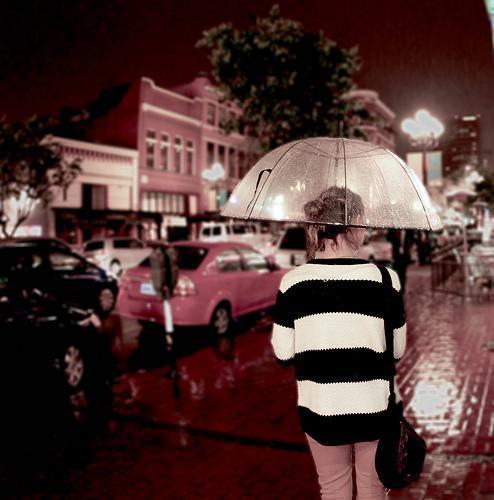How many people are on the sidewalk?
Give a very brief answer. 1. How many umbrellas can be seen in the photo?
Give a very brief answer. 1. 